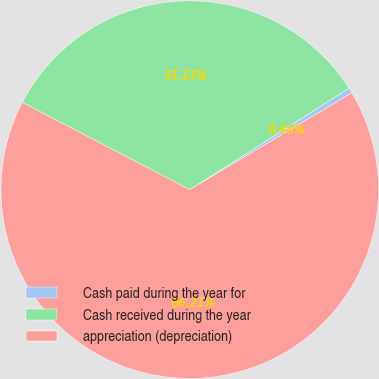<chart> <loc_0><loc_0><loc_500><loc_500><pie_chart><fcel>Cash paid during the year for<fcel>Cash received during the year<fcel>appreciation (depreciation)<nl><fcel>0.46%<fcel>33.33%<fcel>66.21%<nl></chart> 